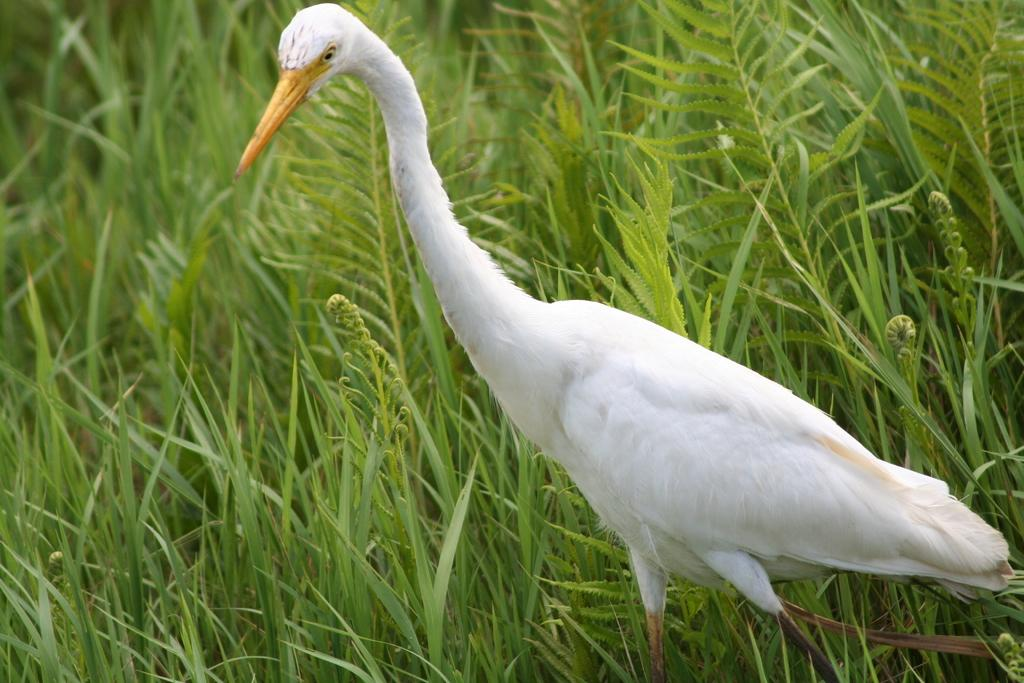What type of bird is in the image? There is a white crane in the image. What color is the crane's beak? The crane has a yellow beak. Where is the crane located in the image? The crane is in the grasses. How many mice are hiding in the grasses with the crane? There is no mention of mice in the image, so we cannot determine if any are present or hiding in the grasses. 